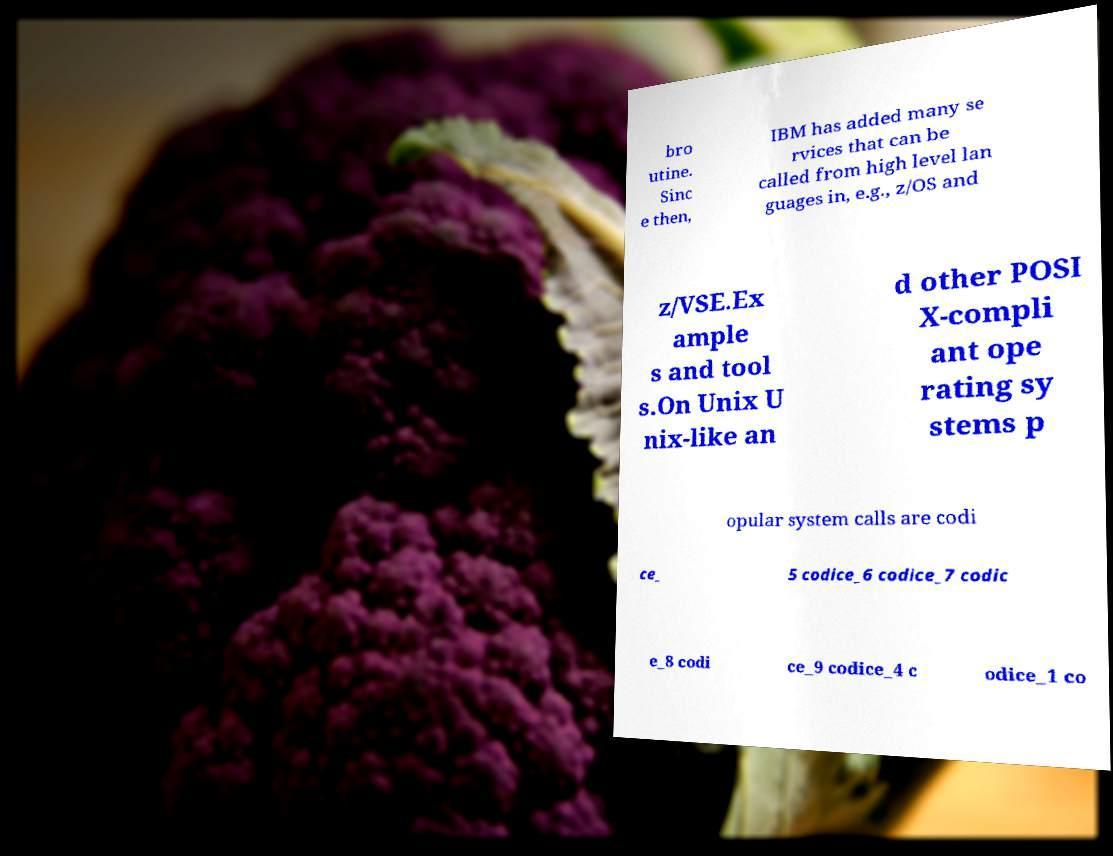There's text embedded in this image that I need extracted. Can you transcribe it verbatim? bro utine. Sinc e then, IBM has added many se rvices that can be called from high level lan guages in, e.g., z/OS and z/VSE.Ex ample s and tool s.On Unix U nix-like an d other POSI X-compli ant ope rating sy stems p opular system calls are codi ce_ 5 codice_6 codice_7 codic e_8 codi ce_9 codice_4 c odice_1 co 